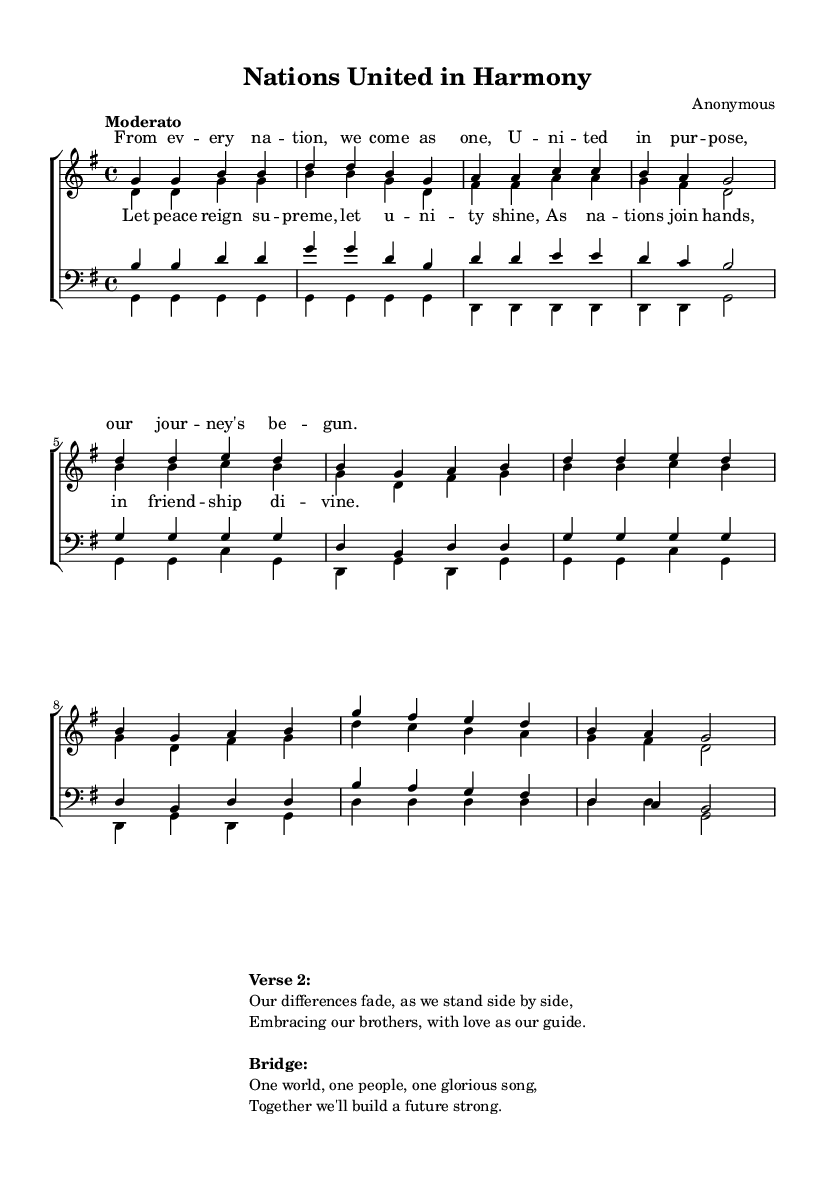What is the key signature of this music? The key signature shown at the beginning indicates G major, which has one sharp (F#).
Answer: G major What is the time signature of this music? The time signature is located near the beginning of the music, and it shows a 4/4 time signature, meaning there are four beats per measure.
Answer: 4/4 What is the tempo marking of this music? The tempo marking is written as "Moderato," indicating a moderate pace for the music, typically around 108-120 beats per minute.
Answer: Moderato What is the title of this piece? The title is displayed in the header section of the sheet music as "Nations United in Harmony."
Answer: Nations United in Harmony How many verses are included in the sheet music? The sheet music includes two verses, as indicated by the existing lyrics present for each section.
Answer: 2 What is the main message conveyed in the chorus? The chorus emphasizes peace and unity, with lyrics that encourage nations to join in friendship and cooperation.
Answer: Peace and unity What type of music is this? This piece is classified as a gospel anthem, characterized by its religious themes focusing on peace and unity.
Answer: Gospel anthem 